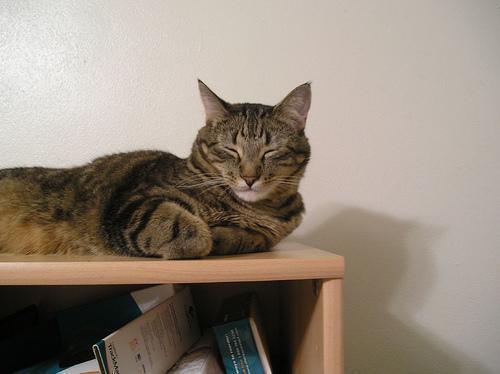What is the cat on top of?
Select the correct answer and articulate reasoning with the following format: 'Answer: answer
Rationale: rationale.'
Options: Box, book shelf, refrigerator, dog. Answer: book shelf.
Rationale: A cat is laying in a shelving unit with books on the shelf below. 